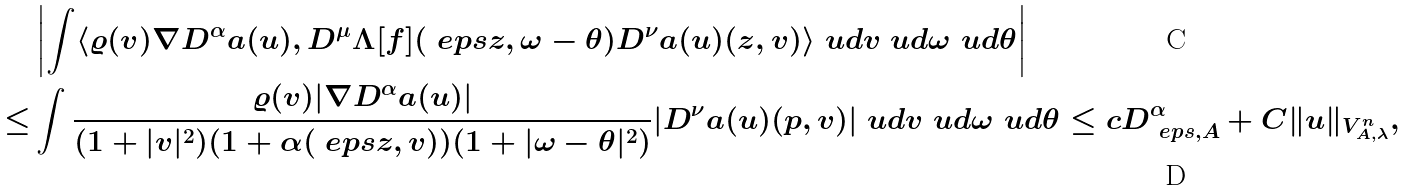<formula> <loc_0><loc_0><loc_500><loc_500>& \left | \int \langle \varrho ( v ) \nabla D ^ { \alpha } \L a ( u ) , D ^ { \mu } \Lambda [ f ] ( \ e p s z , \omega - \theta ) D ^ { \nu } \L a ( u ) ( z , v ) \rangle \ u d { v } \ u d { \omega } \ u d { \theta } \right | \\ \leq & \int \frac { \varrho ( v ) | \nabla D ^ { \alpha } \L a ( u ) | } { ( 1 + | v | ^ { 2 } ) ( 1 + \alpha ( \ e p s z , v ) ) ( 1 + | \omega - \theta | ^ { 2 } ) } | D ^ { \nu } \L a ( u ) ( p , v ) | \ u d { v } \ u d { \omega } \ u d { \theta } \leq c D ^ { \alpha } _ { \ e p s , A } + C \| u \| _ { V ^ { n } _ { A , \lambda } } ,</formula> 